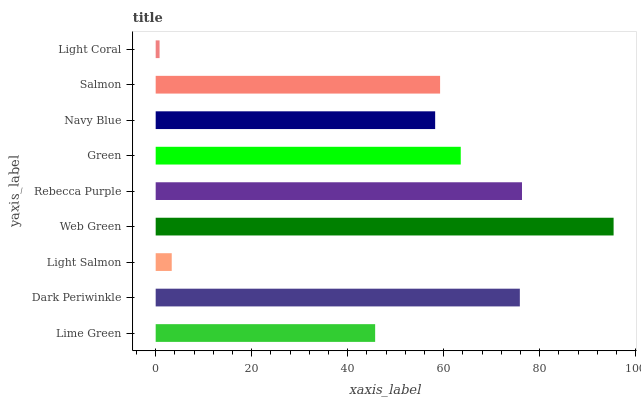Is Light Coral the minimum?
Answer yes or no. Yes. Is Web Green the maximum?
Answer yes or no. Yes. Is Dark Periwinkle the minimum?
Answer yes or no. No. Is Dark Periwinkle the maximum?
Answer yes or no. No. Is Dark Periwinkle greater than Lime Green?
Answer yes or no. Yes. Is Lime Green less than Dark Periwinkle?
Answer yes or no. Yes. Is Lime Green greater than Dark Periwinkle?
Answer yes or no. No. Is Dark Periwinkle less than Lime Green?
Answer yes or no. No. Is Salmon the high median?
Answer yes or no. Yes. Is Salmon the low median?
Answer yes or no. Yes. Is Rebecca Purple the high median?
Answer yes or no. No. Is Lime Green the low median?
Answer yes or no. No. 